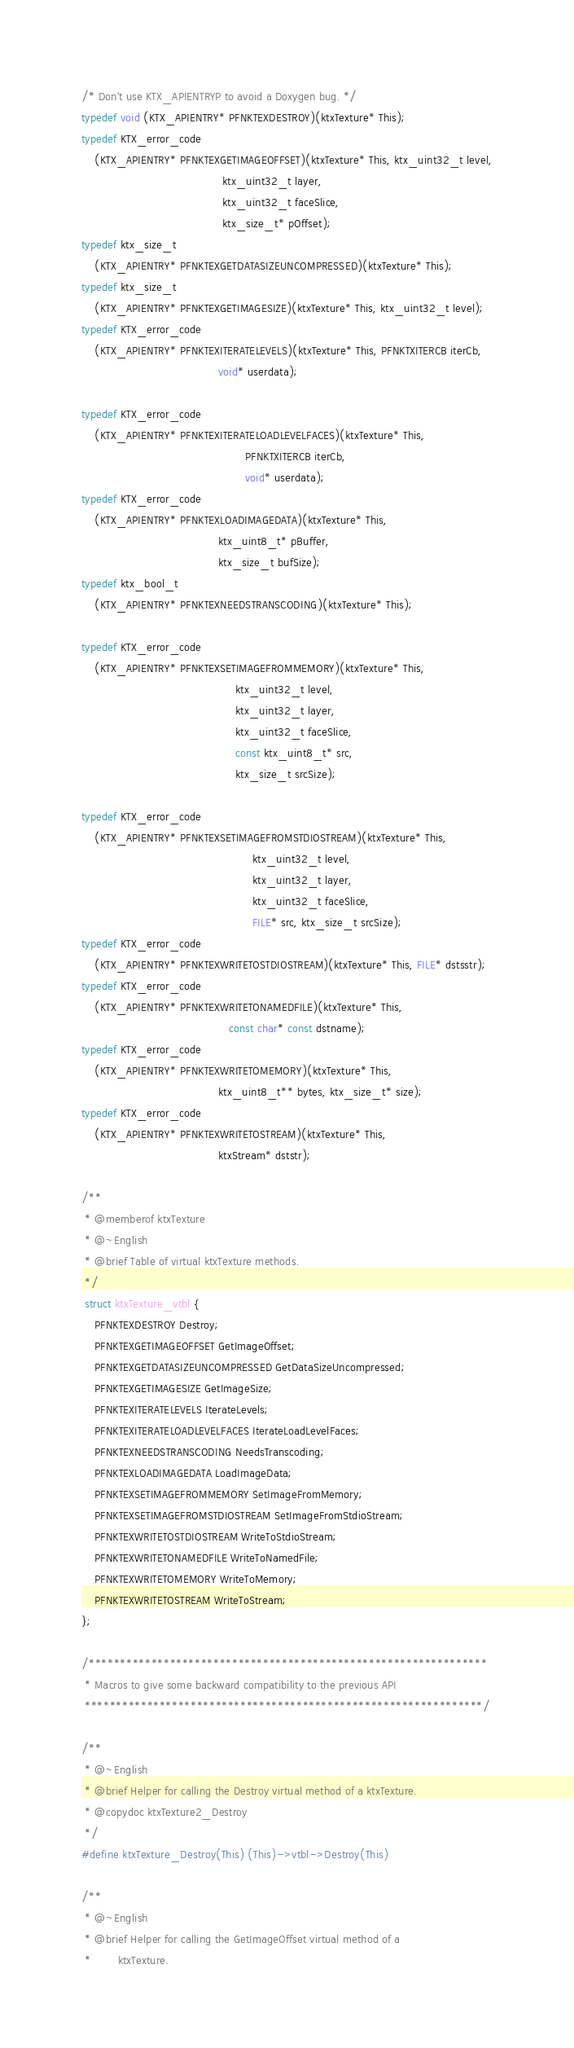Convert code to text. <code><loc_0><loc_0><loc_500><loc_500><_C_>/* Don't use KTX_APIENTRYP to avoid a Doxygen bug. */
typedef void (KTX_APIENTRY* PFNKTEXDESTROY)(ktxTexture* This);
typedef KTX_error_code
    (KTX_APIENTRY* PFNKTEXGETIMAGEOFFSET)(ktxTexture* This, ktx_uint32_t level,
                                          ktx_uint32_t layer,
                                          ktx_uint32_t faceSlice,
                                          ktx_size_t* pOffset);
typedef ktx_size_t
    (KTX_APIENTRY* PFNKTEXGETDATASIZEUNCOMPRESSED)(ktxTexture* This);
typedef ktx_size_t
    (KTX_APIENTRY* PFNKTEXGETIMAGESIZE)(ktxTexture* This, ktx_uint32_t level);
typedef KTX_error_code
    (KTX_APIENTRY* PFNKTEXITERATELEVELS)(ktxTexture* This, PFNKTXITERCB iterCb,
                                         void* userdata);

typedef KTX_error_code
    (KTX_APIENTRY* PFNKTEXITERATELOADLEVELFACES)(ktxTexture* This,
                                                 PFNKTXITERCB iterCb,
                                                 void* userdata);
typedef KTX_error_code
    (KTX_APIENTRY* PFNKTEXLOADIMAGEDATA)(ktxTexture* This,
                                         ktx_uint8_t* pBuffer,
                                         ktx_size_t bufSize);
typedef ktx_bool_t
    (KTX_APIENTRY* PFNKTEXNEEDSTRANSCODING)(ktxTexture* This);

typedef KTX_error_code
    (KTX_APIENTRY* PFNKTEXSETIMAGEFROMMEMORY)(ktxTexture* This,
                                              ktx_uint32_t level,
                                              ktx_uint32_t layer,
                                              ktx_uint32_t faceSlice,
                                              const ktx_uint8_t* src,
                                              ktx_size_t srcSize);

typedef KTX_error_code
    (KTX_APIENTRY* PFNKTEXSETIMAGEFROMSTDIOSTREAM)(ktxTexture* This,
                                                   ktx_uint32_t level,
                                                   ktx_uint32_t layer,
                                                   ktx_uint32_t faceSlice,
                                                   FILE* src, ktx_size_t srcSize);
typedef KTX_error_code
    (KTX_APIENTRY* PFNKTEXWRITETOSTDIOSTREAM)(ktxTexture* This, FILE* dstsstr);
typedef KTX_error_code
    (KTX_APIENTRY* PFNKTEXWRITETONAMEDFILE)(ktxTexture* This,
                                            const char* const dstname);
typedef KTX_error_code
    (KTX_APIENTRY* PFNKTEXWRITETOMEMORY)(ktxTexture* This,
                                         ktx_uint8_t** bytes, ktx_size_t* size);
typedef KTX_error_code
    (KTX_APIENTRY* PFNKTEXWRITETOSTREAM)(ktxTexture* This,
                                         ktxStream* dststr);

/**
 * @memberof ktxTexture
 * @~English
 * @brief Table of virtual ktxTexture methods.
 */
 struct ktxTexture_vtbl {
    PFNKTEXDESTROY Destroy;
    PFNKTEXGETIMAGEOFFSET GetImageOffset;
    PFNKTEXGETDATASIZEUNCOMPRESSED GetDataSizeUncompressed;
    PFNKTEXGETIMAGESIZE GetImageSize;
    PFNKTEXITERATELEVELS IterateLevels;
    PFNKTEXITERATELOADLEVELFACES IterateLoadLevelFaces;
    PFNKTEXNEEDSTRANSCODING NeedsTranscoding;
    PFNKTEXLOADIMAGEDATA LoadImageData;
    PFNKTEXSETIMAGEFROMMEMORY SetImageFromMemory;
    PFNKTEXSETIMAGEFROMSTDIOSTREAM SetImageFromStdioStream;
    PFNKTEXWRITETOSTDIOSTREAM WriteToStdioStream;
    PFNKTEXWRITETONAMEDFILE WriteToNamedFile;
    PFNKTEXWRITETOMEMORY WriteToMemory;
    PFNKTEXWRITETOSTREAM WriteToStream;
};

/****************************************************************
 * Macros to give some backward compatibility to the previous API
 ****************************************************************/

/**
 * @~English
 * @brief Helper for calling the Destroy virtual method of a ktxTexture.
 * @copydoc ktxTexture2_Destroy
 */
#define ktxTexture_Destroy(This) (This)->vtbl->Destroy(This)

/**
 * @~English
 * @brief Helper for calling the GetImageOffset virtual method of a
 *        ktxTexture.</code> 